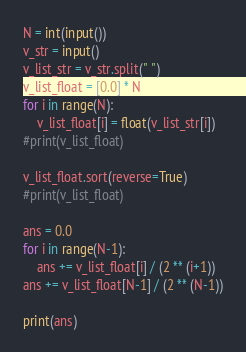<code> <loc_0><loc_0><loc_500><loc_500><_Python_>N = int(input())
v_str = input()
v_list_str = v_str.split(" ")
v_list_float = [0.0] * N
for i in range(N):
    v_list_float[i] = float(v_list_str[i])
#print(v_list_float)

v_list_float.sort(reverse=True)
#print(v_list_float)

ans = 0.0
for i in range(N-1):
    ans += v_list_float[i] / (2 ** (i+1))
ans += v_list_float[N-1] / (2 ** (N-1))

print(ans)
</code> 